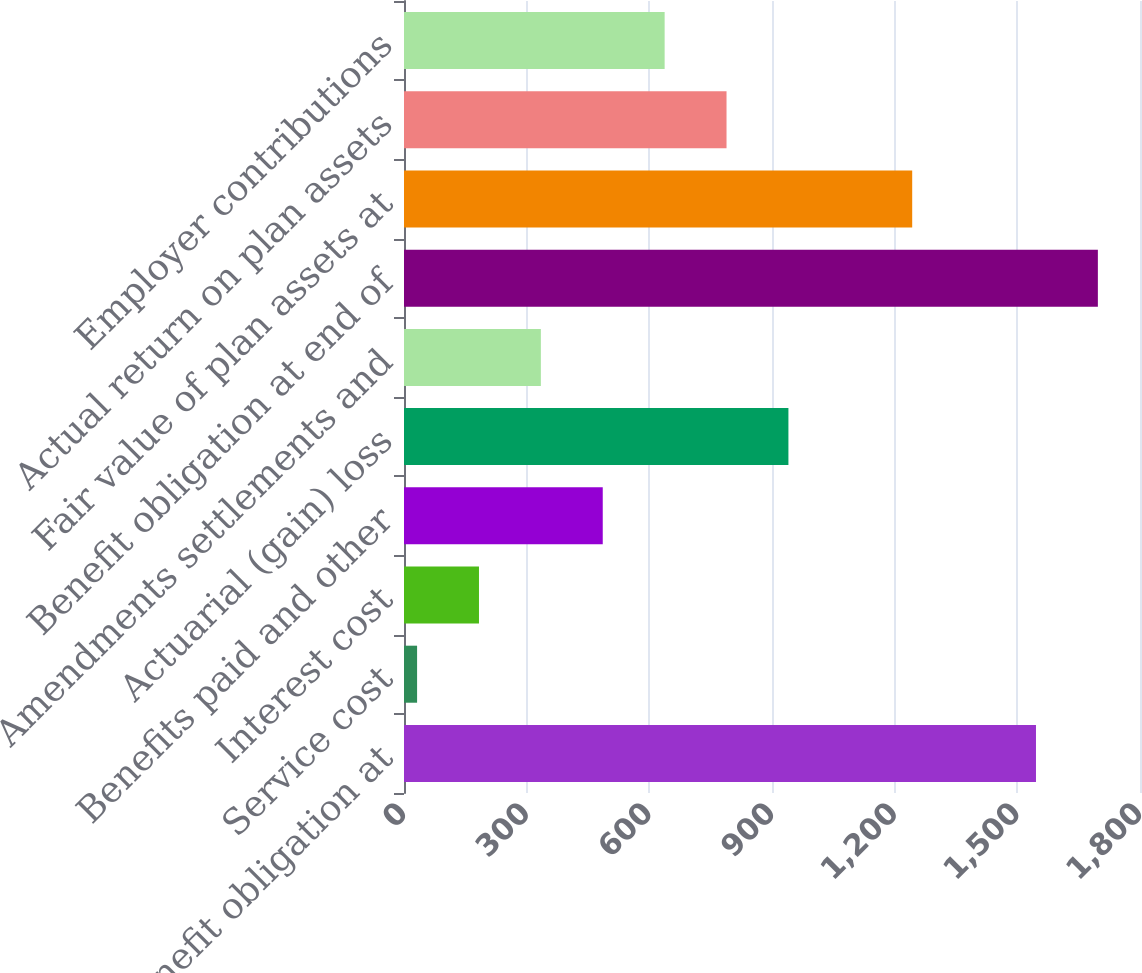Convert chart. <chart><loc_0><loc_0><loc_500><loc_500><bar_chart><fcel>Benefit obligation at<fcel>Service cost<fcel>Interest cost<fcel>Benefits paid and other<fcel>Actuarial (gain) loss<fcel>Amendments settlements and<fcel>Benefit obligation at end of<fcel>Fair value of plan assets at<fcel>Actual return on plan assets<fcel>Employer contributions<nl><fcel>1545.6<fcel>32<fcel>183.36<fcel>486.08<fcel>940.16<fcel>334.72<fcel>1696.96<fcel>1242.88<fcel>788.8<fcel>637.44<nl></chart> 